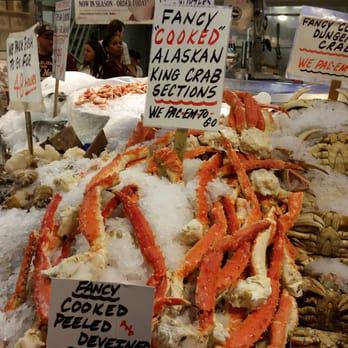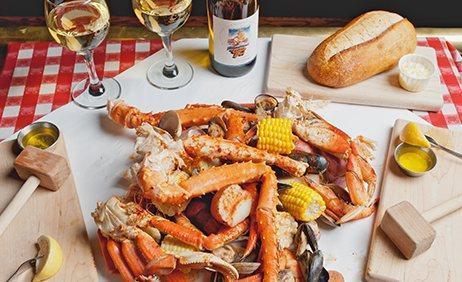The first image is the image on the left, the second image is the image on the right. For the images displayed, is the sentence "In one image, a man near a display of iced fish has his arms outstretched, while a second image shows iced crabs and crab legs for sale." factually correct? Answer yes or no. No. The first image is the image on the left, the second image is the image on the right. For the images shown, is this caption "An image shows a man standing in front of a display of fish with his arms raised to catch a fish coming toward him." true? Answer yes or no. No. 